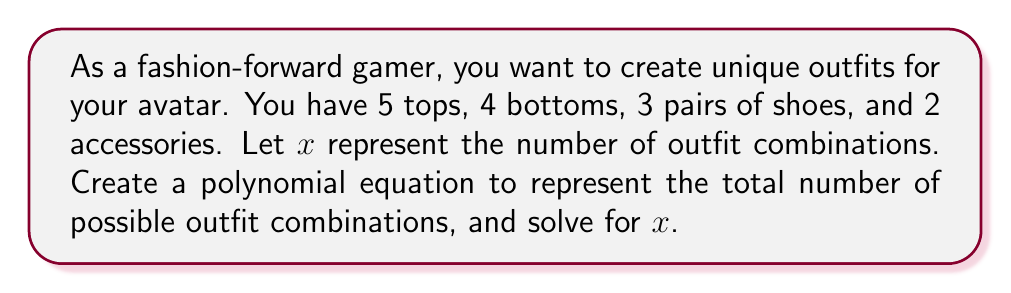Teach me how to tackle this problem. Let's approach this step-by-step:

1) First, we need to understand the fundamental counting principle. When we have independent choices, we multiply the number of options for each choice.

2) In this case, we have:
   - 5 choices for tops
   - 4 choices for bottoms
   - 3 choices for shoes
   - 2 choices for accessories

3) We can represent this as a polynomial equation:

   $$x = 5 \cdot 4 \cdot 3 \cdot 2$$

4) This simplifies to:

   $$x = 120$$

5) However, we can also express this as a polynomial in a more complex way:

   $$x = (5t + 4b + 3s + 2a) - (5t + 4b + 3s + 2a - 120)$$

   Where $t$, $b$, $s$, and $a$ are variables representing tops, bottoms, shoes, and accessories respectively.

6) The first part $(5t + 4b + 3s + 2a)$ represents the sum of all individual items.

7) The second part $(5t + 4b + 3s + 2a - 120)$ is subtracted to account for the overcounting and leave us with the correct total.

8) Simplifying this equation:

   $$x = 120$$

Thus, the polynomial equation represents the total number of possible outfit combinations, which is 120.
Answer: 120 